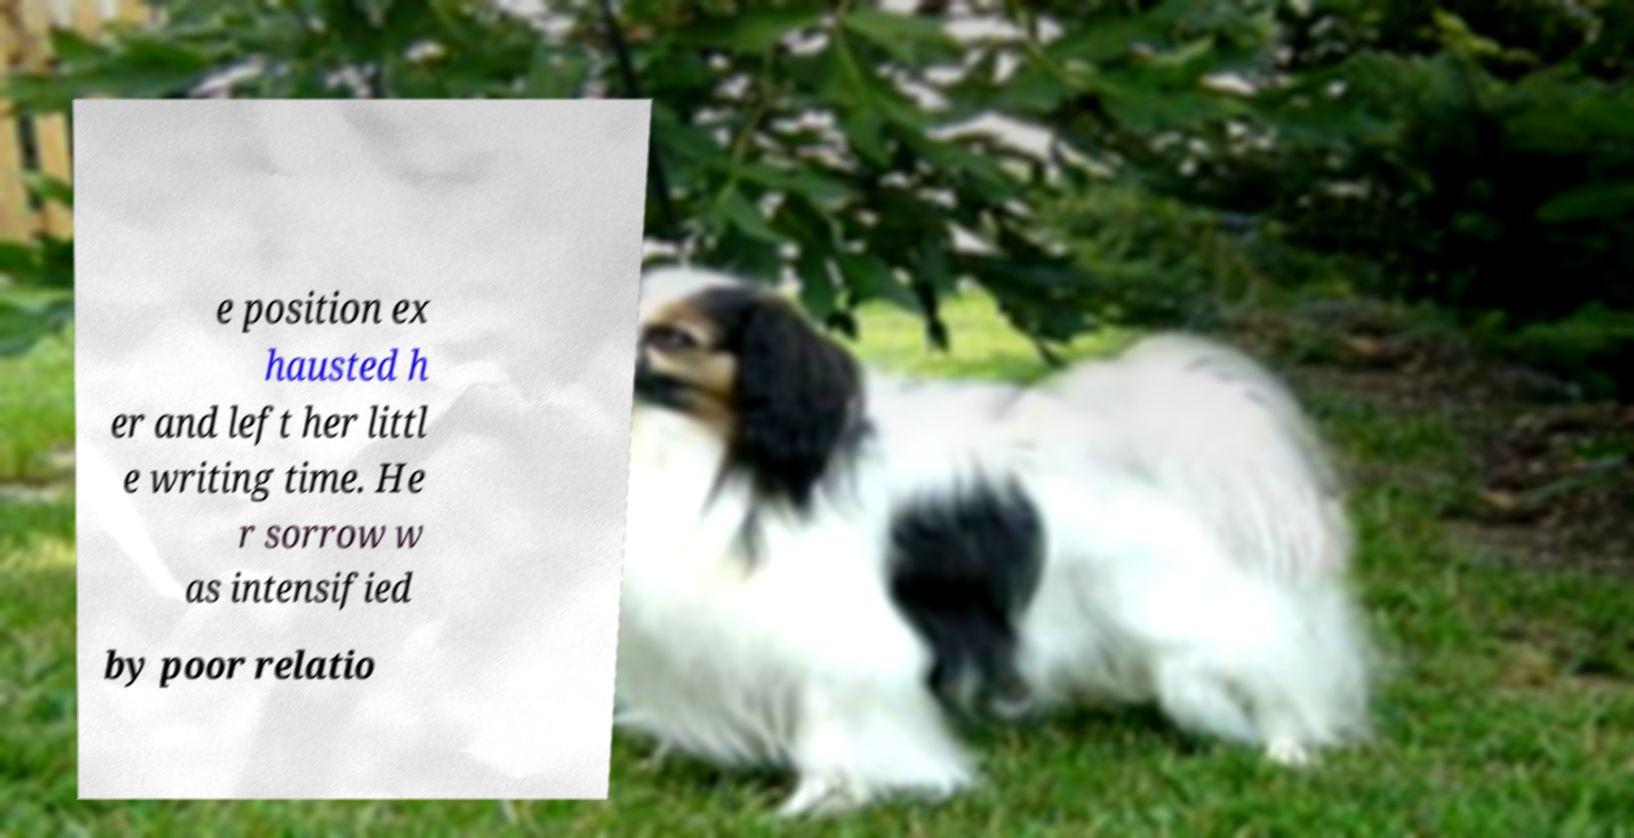Can you read and provide the text displayed in the image?This photo seems to have some interesting text. Can you extract and type it out for me? e position ex hausted h er and left her littl e writing time. He r sorrow w as intensified by poor relatio 